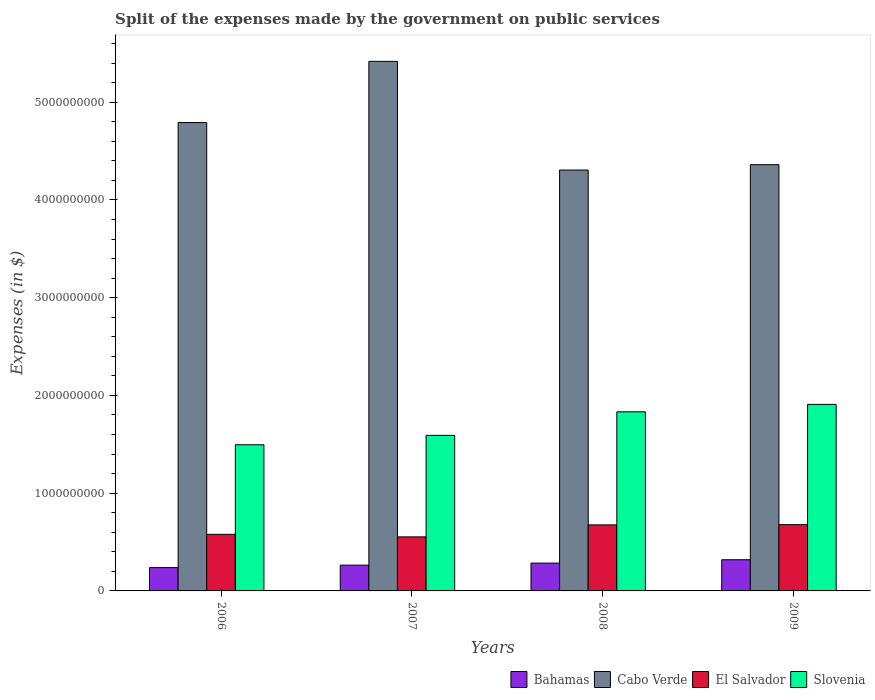Are the number of bars per tick equal to the number of legend labels?
Give a very brief answer. Yes. How many bars are there on the 1st tick from the left?
Offer a very short reply. 4. What is the label of the 2nd group of bars from the left?
Your answer should be very brief. 2007. What is the expenses made by the government on public services in Slovenia in 2006?
Your response must be concise. 1.50e+09. Across all years, what is the maximum expenses made by the government on public services in Cabo Verde?
Give a very brief answer. 5.42e+09. Across all years, what is the minimum expenses made by the government on public services in Bahamas?
Your response must be concise. 2.39e+08. What is the total expenses made by the government on public services in Cabo Verde in the graph?
Make the answer very short. 1.89e+1. What is the difference between the expenses made by the government on public services in Bahamas in 2007 and that in 2009?
Ensure brevity in your answer.  -5.55e+07. What is the difference between the expenses made by the government on public services in Slovenia in 2007 and the expenses made by the government on public services in Cabo Verde in 2009?
Provide a short and direct response. -2.77e+09. What is the average expenses made by the government on public services in El Salvador per year?
Provide a succinct answer. 6.21e+08. In the year 2006, what is the difference between the expenses made by the government on public services in El Salvador and expenses made by the government on public services in Bahamas?
Offer a terse response. 3.41e+08. What is the ratio of the expenses made by the government on public services in Cabo Verde in 2006 to that in 2007?
Provide a succinct answer. 0.88. What is the difference between the highest and the second highest expenses made by the government on public services in El Salvador?
Your answer should be compact. 2.60e+06. What is the difference between the highest and the lowest expenses made by the government on public services in El Salvador?
Your answer should be compact. 1.25e+08. In how many years, is the expenses made by the government on public services in Slovenia greater than the average expenses made by the government on public services in Slovenia taken over all years?
Your answer should be very brief. 2. Is it the case that in every year, the sum of the expenses made by the government on public services in Slovenia and expenses made by the government on public services in Bahamas is greater than the sum of expenses made by the government on public services in Cabo Verde and expenses made by the government on public services in El Salvador?
Provide a short and direct response. Yes. What does the 2nd bar from the left in 2008 represents?
Offer a terse response. Cabo Verde. What does the 3rd bar from the right in 2006 represents?
Provide a succinct answer. Cabo Verde. How many bars are there?
Your answer should be very brief. 16. Are the values on the major ticks of Y-axis written in scientific E-notation?
Keep it short and to the point. No. Does the graph contain any zero values?
Provide a short and direct response. No. How many legend labels are there?
Offer a very short reply. 4. What is the title of the graph?
Offer a very short reply. Split of the expenses made by the government on public services. What is the label or title of the X-axis?
Make the answer very short. Years. What is the label or title of the Y-axis?
Your response must be concise. Expenses (in $). What is the Expenses (in $) of Bahamas in 2006?
Make the answer very short. 2.39e+08. What is the Expenses (in $) in Cabo Verde in 2006?
Keep it short and to the point. 4.79e+09. What is the Expenses (in $) of El Salvador in 2006?
Ensure brevity in your answer.  5.79e+08. What is the Expenses (in $) in Slovenia in 2006?
Provide a short and direct response. 1.50e+09. What is the Expenses (in $) in Bahamas in 2007?
Give a very brief answer. 2.64e+08. What is the Expenses (in $) of Cabo Verde in 2007?
Your answer should be very brief. 5.42e+09. What is the Expenses (in $) of El Salvador in 2007?
Your response must be concise. 5.53e+08. What is the Expenses (in $) of Slovenia in 2007?
Your response must be concise. 1.59e+09. What is the Expenses (in $) in Bahamas in 2008?
Offer a very short reply. 2.85e+08. What is the Expenses (in $) of Cabo Verde in 2008?
Provide a succinct answer. 4.31e+09. What is the Expenses (in $) of El Salvador in 2008?
Your response must be concise. 6.76e+08. What is the Expenses (in $) of Slovenia in 2008?
Offer a terse response. 1.83e+09. What is the Expenses (in $) in Bahamas in 2009?
Provide a succinct answer. 3.19e+08. What is the Expenses (in $) in Cabo Verde in 2009?
Your answer should be very brief. 4.36e+09. What is the Expenses (in $) in El Salvador in 2009?
Provide a succinct answer. 6.78e+08. What is the Expenses (in $) in Slovenia in 2009?
Keep it short and to the point. 1.91e+09. Across all years, what is the maximum Expenses (in $) of Bahamas?
Your response must be concise. 3.19e+08. Across all years, what is the maximum Expenses (in $) of Cabo Verde?
Make the answer very short. 5.42e+09. Across all years, what is the maximum Expenses (in $) in El Salvador?
Your answer should be compact. 6.78e+08. Across all years, what is the maximum Expenses (in $) in Slovenia?
Offer a very short reply. 1.91e+09. Across all years, what is the minimum Expenses (in $) of Bahamas?
Make the answer very short. 2.39e+08. Across all years, what is the minimum Expenses (in $) of Cabo Verde?
Your answer should be very brief. 4.31e+09. Across all years, what is the minimum Expenses (in $) of El Salvador?
Your answer should be very brief. 5.53e+08. Across all years, what is the minimum Expenses (in $) in Slovenia?
Provide a succinct answer. 1.50e+09. What is the total Expenses (in $) of Bahamas in the graph?
Offer a very short reply. 1.11e+09. What is the total Expenses (in $) of Cabo Verde in the graph?
Ensure brevity in your answer.  1.89e+1. What is the total Expenses (in $) in El Salvador in the graph?
Your answer should be very brief. 2.49e+09. What is the total Expenses (in $) of Slovenia in the graph?
Make the answer very short. 6.83e+09. What is the difference between the Expenses (in $) in Bahamas in 2006 and that in 2007?
Provide a short and direct response. -2.51e+07. What is the difference between the Expenses (in $) of Cabo Verde in 2006 and that in 2007?
Give a very brief answer. -6.26e+08. What is the difference between the Expenses (in $) in El Salvador in 2006 and that in 2007?
Offer a very short reply. 2.62e+07. What is the difference between the Expenses (in $) in Slovenia in 2006 and that in 2007?
Provide a succinct answer. -9.62e+07. What is the difference between the Expenses (in $) of Bahamas in 2006 and that in 2008?
Provide a short and direct response. -4.60e+07. What is the difference between the Expenses (in $) of Cabo Verde in 2006 and that in 2008?
Offer a very short reply. 4.86e+08. What is the difference between the Expenses (in $) in El Salvador in 2006 and that in 2008?
Your answer should be very brief. -9.65e+07. What is the difference between the Expenses (in $) in Slovenia in 2006 and that in 2008?
Your response must be concise. -3.37e+08. What is the difference between the Expenses (in $) in Bahamas in 2006 and that in 2009?
Keep it short and to the point. -8.05e+07. What is the difference between the Expenses (in $) of Cabo Verde in 2006 and that in 2009?
Your response must be concise. 4.31e+08. What is the difference between the Expenses (in $) of El Salvador in 2006 and that in 2009?
Ensure brevity in your answer.  -9.91e+07. What is the difference between the Expenses (in $) of Slovenia in 2006 and that in 2009?
Keep it short and to the point. -4.13e+08. What is the difference between the Expenses (in $) of Bahamas in 2007 and that in 2008?
Keep it short and to the point. -2.10e+07. What is the difference between the Expenses (in $) of Cabo Verde in 2007 and that in 2008?
Offer a terse response. 1.11e+09. What is the difference between the Expenses (in $) of El Salvador in 2007 and that in 2008?
Your response must be concise. -1.23e+08. What is the difference between the Expenses (in $) of Slovenia in 2007 and that in 2008?
Ensure brevity in your answer.  -2.41e+08. What is the difference between the Expenses (in $) of Bahamas in 2007 and that in 2009?
Provide a succinct answer. -5.55e+07. What is the difference between the Expenses (in $) in Cabo Verde in 2007 and that in 2009?
Your response must be concise. 1.06e+09. What is the difference between the Expenses (in $) in El Salvador in 2007 and that in 2009?
Provide a short and direct response. -1.25e+08. What is the difference between the Expenses (in $) in Slovenia in 2007 and that in 2009?
Offer a terse response. -3.17e+08. What is the difference between the Expenses (in $) of Bahamas in 2008 and that in 2009?
Your answer should be very brief. -3.45e+07. What is the difference between the Expenses (in $) of Cabo Verde in 2008 and that in 2009?
Give a very brief answer. -5.47e+07. What is the difference between the Expenses (in $) of El Salvador in 2008 and that in 2009?
Your answer should be very brief. -2.60e+06. What is the difference between the Expenses (in $) of Slovenia in 2008 and that in 2009?
Your response must be concise. -7.61e+07. What is the difference between the Expenses (in $) of Bahamas in 2006 and the Expenses (in $) of Cabo Verde in 2007?
Make the answer very short. -5.18e+09. What is the difference between the Expenses (in $) of Bahamas in 2006 and the Expenses (in $) of El Salvador in 2007?
Provide a succinct answer. -3.14e+08. What is the difference between the Expenses (in $) of Bahamas in 2006 and the Expenses (in $) of Slovenia in 2007?
Keep it short and to the point. -1.35e+09. What is the difference between the Expenses (in $) in Cabo Verde in 2006 and the Expenses (in $) in El Salvador in 2007?
Provide a short and direct response. 4.24e+09. What is the difference between the Expenses (in $) in Cabo Verde in 2006 and the Expenses (in $) in Slovenia in 2007?
Your answer should be compact. 3.20e+09. What is the difference between the Expenses (in $) in El Salvador in 2006 and the Expenses (in $) in Slovenia in 2007?
Provide a short and direct response. -1.01e+09. What is the difference between the Expenses (in $) of Bahamas in 2006 and the Expenses (in $) of Cabo Verde in 2008?
Provide a short and direct response. -4.07e+09. What is the difference between the Expenses (in $) in Bahamas in 2006 and the Expenses (in $) in El Salvador in 2008?
Give a very brief answer. -4.37e+08. What is the difference between the Expenses (in $) of Bahamas in 2006 and the Expenses (in $) of Slovenia in 2008?
Your response must be concise. -1.59e+09. What is the difference between the Expenses (in $) in Cabo Verde in 2006 and the Expenses (in $) in El Salvador in 2008?
Provide a succinct answer. 4.12e+09. What is the difference between the Expenses (in $) in Cabo Verde in 2006 and the Expenses (in $) in Slovenia in 2008?
Provide a short and direct response. 2.96e+09. What is the difference between the Expenses (in $) of El Salvador in 2006 and the Expenses (in $) of Slovenia in 2008?
Your response must be concise. -1.25e+09. What is the difference between the Expenses (in $) of Bahamas in 2006 and the Expenses (in $) of Cabo Verde in 2009?
Your response must be concise. -4.12e+09. What is the difference between the Expenses (in $) in Bahamas in 2006 and the Expenses (in $) in El Salvador in 2009?
Your answer should be compact. -4.40e+08. What is the difference between the Expenses (in $) in Bahamas in 2006 and the Expenses (in $) in Slovenia in 2009?
Offer a terse response. -1.67e+09. What is the difference between the Expenses (in $) of Cabo Verde in 2006 and the Expenses (in $) of El Salvador in 2009?
Make the answer very short. 4.11e+09. What is the difference between the Expenses (in $) in Cabo Verde in 2006 and the Expenses (in $) in Slovenia in 2009?
Provide a short and direct response. 2.88e+09. What is the difference between the Expenses (in $) in El Salvador in 2006 and the Expenses (in $) in Slovenia in 2009?
Your response must be concise. -1.33e+09. What is the difference between the Expenses (in $) of Bahamas in 2007 and the Expenses (in $) of Cabo Verde in 2008?
Offer a very short reply. -4.04e+09. What is the difference between the Expenses (in $) of Bahamas in 2007 and the Expenses (in $) of El Salvador in 2008?
Provide a succinct answer. -4.12e+08. What is the difference between the Expenses (in $) in Bahamas in 2007 and the Expenses (in $) in Slovenia in 2008?
Your answer should be compact. -1.57e+09. What is the difference between the Expenses (in $) in Cabo Verde in 2007 and the Expenses (in $) in El Salvador in 2008?
Give a very brief answer. 4.74e+09. What is the difference between the Expenses (in $) of Cabo Verde in 2007 and the Expenses (in $) of Slovenia in 2008?
Offer a very short reply. 3.59e+09. What is the difference between the Expenses (in $) of El Salvador in 2007 and the Expenses (in $) of Slovenia in 2008?
Your answer should be compact. -1.28e+09. What is the difference between the Expenses (in $) in Bahamas in 2007 and the Expenses (in $) in Cabo Verde in 2009?
Make the answer very short. -4.10e+09. What is the difference between the Expenses (in $) in Bahamas in 2007 and the Expenses (in $) in El Salvador in 2009?
Keep it short and to the point. -4.15e+08. What is the difference between the Expenses (in $) of Bahamas in 2007 and the Expenses (in $) of Slovenia in 2009?
Give a very brief answer. -1.64e+09. What is the difference between the Expenses (in $) of Cabo Verde in 2007 and the Expenses (in $) of El Salvador in 2009?
Give a very brief answer. 4.74e+09. What is the difference between the Expenses (in $) in Cabo Verde in 2007 and the Expenses (in $) in Slovenia in 2009?
Provide a succinct answer. 3.51e+09. What is the difference between the Expenses (in $) of El Salvador in 2007 and the Expenses (in $) of Slovenia in 2009?
Your answer should be compact. -1.36e+09. What is the difference between the Expenses (in $) in Bahamas in 2008 and the Expenses (in $) in Cabo Verde in 2009?
Provide a short and direct response. -4.08e+09. What is the difference between the Expenses (in $) of Bahamas in 2008 and the Expenses (in $) of El Salvador in 2009?
Provide a short and direct response. -3.94e+08. What is the difference between the Expenses (in $) in Bahamas in 2008 and the Expenses (in $) in Slovenia in 2009?
Your answer should be very brief. -1.62e+09. What is the difference between the Expenses (in $) in Cabo Verde in 2008 and the Expenses (in $) in El Salvador in 2009?
Your answer should be very brief. 3.63e+09. What is the difference between the Expenses (in $) in Cabo Verde in 2008 and the Expenses (in $) in Slovenia in 2009?
Give a very brief answer. 2.40e+09. What is the difference between the Expenses (in $) of El Salvador in 2008 and the Expenses (in $) of Slovenia in 2009?
Keep it short and to the point. -1.23e+09. What is the average Expenses (in $) of Bahamas per year?
Your response must be concise. 2.76e+08. What is the average Expenses (in $) of Cabo Verde per year?
Your answer should be very brief. 4.72e+09. What is the average Expenses (in $) of El Salvador per year?
Provide a short and direct response. 6.21e+08. What is the average Expenses (in $) of Slovenia per year?
Provide a succinct answer. 1.71e+09. In the year 2006, what is the difference between the Expenses (in $) in Bahamas and Expenses (in $) in Cabo Verde?
Ensure brevity in your answer.  -4.55e+09. In the year 2006, what is the difference between the Expenses (in $) of Bahamas and Expenses (in $) of El Salvador?
Offer a very short reply. -3.41e+08. In the year 2006, what is the difference between the Expenses (in $) in Bahamas and Expenses (in $) in Slovenia?
Give a very brief answer. -1.26e+09. In the year 2006, what is the difference between the Expenses (in $) in Cabo Verde and Expenses (in $) in El Salvador?
Ensure brevity in your answer.  4.21e+09. In the year 2006, what is the difference between the Expenses (in $) in Cabo Verde and Expenses (in $) in Slovenia?
Your response must be concise. 3.30e+09. In the year 2006, what is the difference between the Expenses (in $) of El Salvador and Expenses (in $) of Slovenia?
Keep it short and to the point. -9.16e+08. In the year 2007, what is the difference between the Expenses (in $) of Bahamas and Expenses (in $) of Cabo Verde?
Make the answer very short. -5.15e+09. In the year 2007, what is the difference between the Expenses (in $) in Bahamas and Expenses (in $) in El Salvador?
Your response must be concise. -2.89e+08. In the year 2007, what is the difference between the Expenses (in $) in Bahamas and Expenses (in $) in Slovenia?
Ensure brevity in your answer.  -1.33e+09. In the year 2007, what is the difference between the Expenses (in $) in Cabo Verde and Expenses (in $) in El Salvador?
Provide a succinct answer. 4.86e+09. In the year 2007, what is the difference between the Expenses (in $) of Cabo Verde and Expenses (in $) of Slovenia?
Offer a very short reply. 3.83e+09. In the year 2007, what is the difference between the Expenses (in $) in El Salvador and Expenses (in $) in Slovenia?
Ensure brevity in your answer.  -1.04e+09. In the year 2008, what is the difference between the Expenses (in $) in Bahamas and Expenses (in $) in Cabo Verde?
Provide a succinct answer. -4.02e+09. In the year 2008, what is the difference between the Expenses (in $) in Bahamas and Expenses (in $) in El Salvador?
Your answer should be very brief. -3.91e+08. In the year 2008, what is the difference between the Expenses (in $) of Bahamas and Expenses (in $) of Slovenia?
Provide a short and direct response. -1.55e+09. In the year 2008, what is the difference between the Expenses (in $) of Cabo Verde and Expenses (in $) of El Salvador?
Provide a succinct answer. 3.63e+09. In the year 2008, what is the difference between the Expenses (in $) of Cabo Verde and Expenses (in $) of Slovenia?
Provide a short and direct response. 2.47e+09. In the year 2008, what is the difference between the Expenses (in $) in El Salvador and Expenses (in $) in Slovenia?
Provide a succinct answer. -1.16e+09. In the year 2009, what is the difference between the Expenses (in $) of Bahamas and Expenses (in $) of Cabo Verde?
Provide a short and direct response. -4.04e+09. In the year 2009, what is the difference between the Expenses (in $) in Bahamas and Expenses (in $) in El Salvador?
Your response must be concise. -3.59e+08. In the year 2009, what is the difference between the Expenses (in $) of Bahamas and Expenses (in $) of Slovenia?
Your answer should be compact. -1.59e+09. In the year 2009, what is the difference between the Expenses (in $) in Cabo Verde and Expenses (in $) in El Salvador?
Make the answer very short. 3.68e+09. In the year 2009, what is the difference between the Expenses (in $) in Cabo Verde and Expenses (in $) in Slovenia?
Keep it short and to the point. 2.45e+09. In the year 2009, what is the difference between the Expenses (in $) in El Salvador and Expenses (in $) in Slovenia?
Make the answer very short. -1.23e+09. What is the ratio of the Expenses (in $) in Bahamas in 2006 to that in 2007?
Keep it short and to the point. 0.91. What is the ratio of the Expenses (in $) of Cabo Verde in 2006 to that in 2007?
Your response must be concise. 0.88. What is the ratio of the Expenses (in $) of El Salvador in 2006 to that in 2007?
Your answer should be very brief. 1.05. What is the ratio of the Expenses (in $) of Slovenia in 2006 to that in 2007?
Offer a very short reply. 0.94. What is the ratio of the Expenses (in $) in Bahamas in 2006 to that in 2008?
Ensure brevity in your answer.  0.84. What is the ratio of the Expenses (in $) of Cabo Verde in 2006 to that in 2008?
Offer a terse response. 1.11. What is the ratio of the Expenses (in $) of El Salvador in 2006 to that in 2008?
Provide a succinct answer. 0.86. What is the ratio of the Expenses (in $) of Slovenia in 2006 to that in 2008?
Your answer should be very brief. 0.82. What is the ratio of the Expenses (in $) in Bahamas in 2006 to that in 2009?
Ensure brevity in your answer.  0.75. What is the ratio of the Expenses (in $) of Cabo Verde in 2006 to that in 2009?
Provide a short and direct response. 1.1. What is the ratio of the Expenses (in $) of El Salvador in 2006 to that in 2009?
Give a very brief answer. 0.85. What is the ratio of the Expenses (in $) of Slovenia in 2006 to that in 2009?
Your response must be concise. 0.78. What is the ratio of the Expenses (in $) of Bahamas in 2007 to that in 2008?
Your answer should be very brief. 0.93. What is the ratio of the Expenses (in $) of Cabo Verde in 2007 to that in 2008?
Give a very brief answer. 1.26. What is the ratio of the Expenses (in $) of El Salvador in 2007 to that in 2008?
Provide a short and direct response. 0.82. What is the ratio of the Expenses (in $) of Slovenia in 2007 to that in 2008?
Ensure brevity in your answer.  0.87. What is the ratio of the Expenses (in $) of Bahamas in 2007 to that in 2009?
Keep it short and to the point. 0.83. What is the ratio of the Expenses (in $) of Cabo Verde in 2007 to that in 2009?
Offer a terse response. 1.24. What is the ratio of the Expenses (in $) of El Salvador in 2007 to that in 2009?
Your response must be concise. 0.82. What is the ratio of the Expenses (in $) in Slovenia in 2007 to that in 2009?
Provide a short and direct response. 0.83. What is the ratio of the Expenses (in $) of Bahamas in 2008 to that in 2009?
Provide a short and direct response. 0.89. What is the ratio of the Expenses (in $) in Cabo Verde in 2008 to that in 2009?
Your answer should be compact. 0.99. What is the ratio of the Expenses (in $) in Slovenia in 2008 to that in 2009?
Give a very brief answer. 0.96. What is the difference between the highest and the second highest Expenses (in $) of Bahamas?
Make the answer very short. 3.45e+07. What is the difference between the highest and the second highest Expenses (in $) in Cabo Verde?
Give a very brief answer. 6.26e+08. What is the difference between the highest and the second highest Expenses (in $) of El Salvador?
Ensure brevity in your answer.  2.60e+06. What is the difference between the highest and the second highest Expenses (in $) of Slovenia?
Your response must be concise. 7.61e+07. What is the difference between the highest and the lowest Expenses (in $) in Bahamas?
Offer a terse response. 8.05e+07. What is the difference between the highest and the lowest Expenses (in $) in Cabo Verde?
Your answer should be very brief. 1.11e+09. What is the difference between the highest and the lowest Expenses (in $) in El Salvador?
Ensure brevity in your answer.  1.25e+08. What is the difference between the highest and the lowest Expenses (in $) in Slovenia?
Offer a terse response. 4.13e+08. 